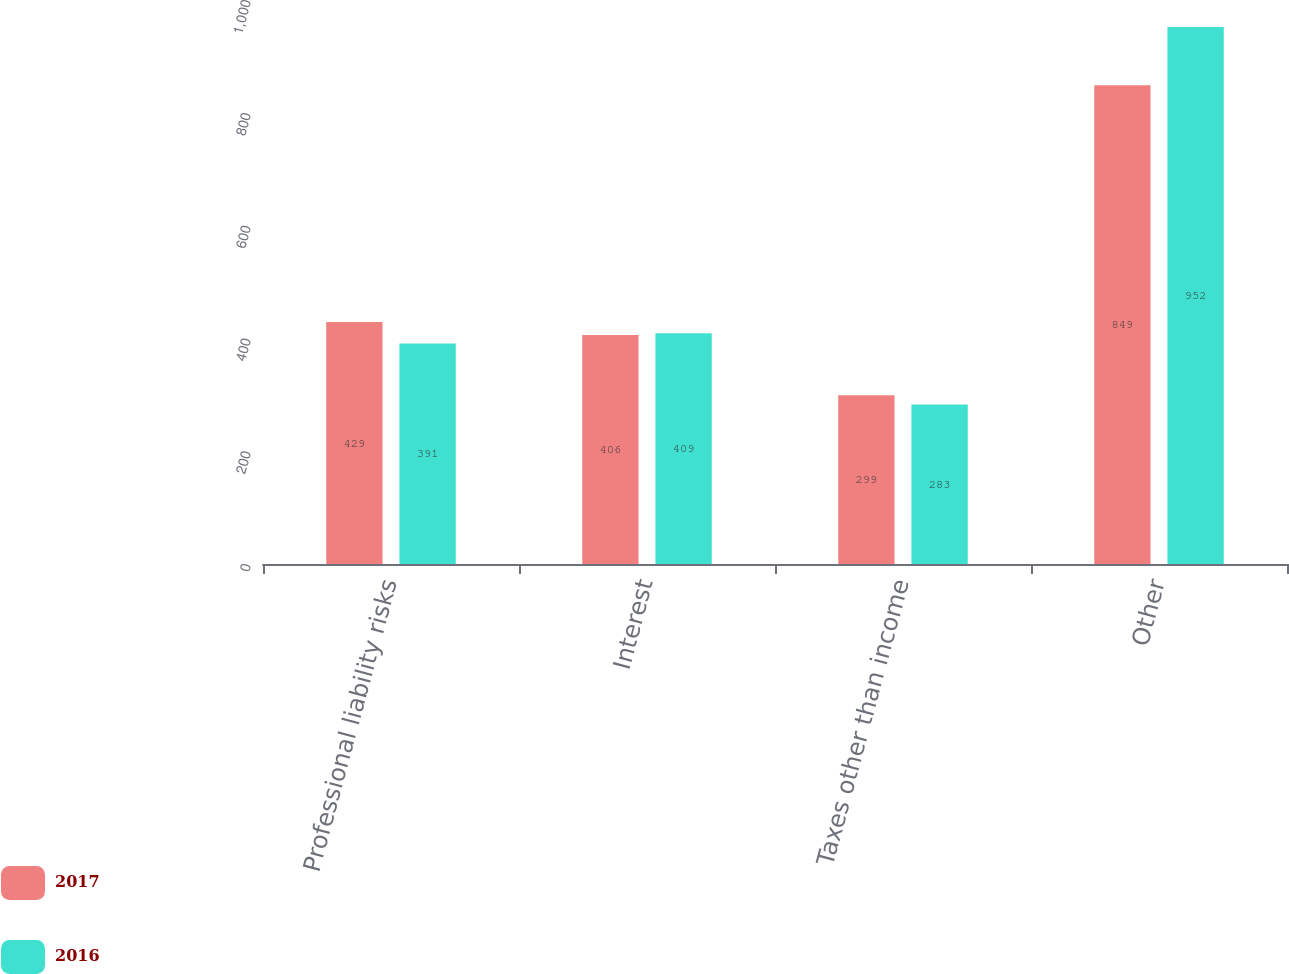Convert chart to OTSL. <chart><loc_0><loc_0><loc_500><loc_500><stacked_bar_chart><ecel><fcel>Professional liability risks<fcel>Interest<fcel>Taxes other than income<fcel>Other<nl><fcel>2017<fcel>429<fcel>406<fcel>299<fcel>849<nl><fcel>2016<fcel>391<fcel>409<fcel>283<fcel>952<nl></chart> 